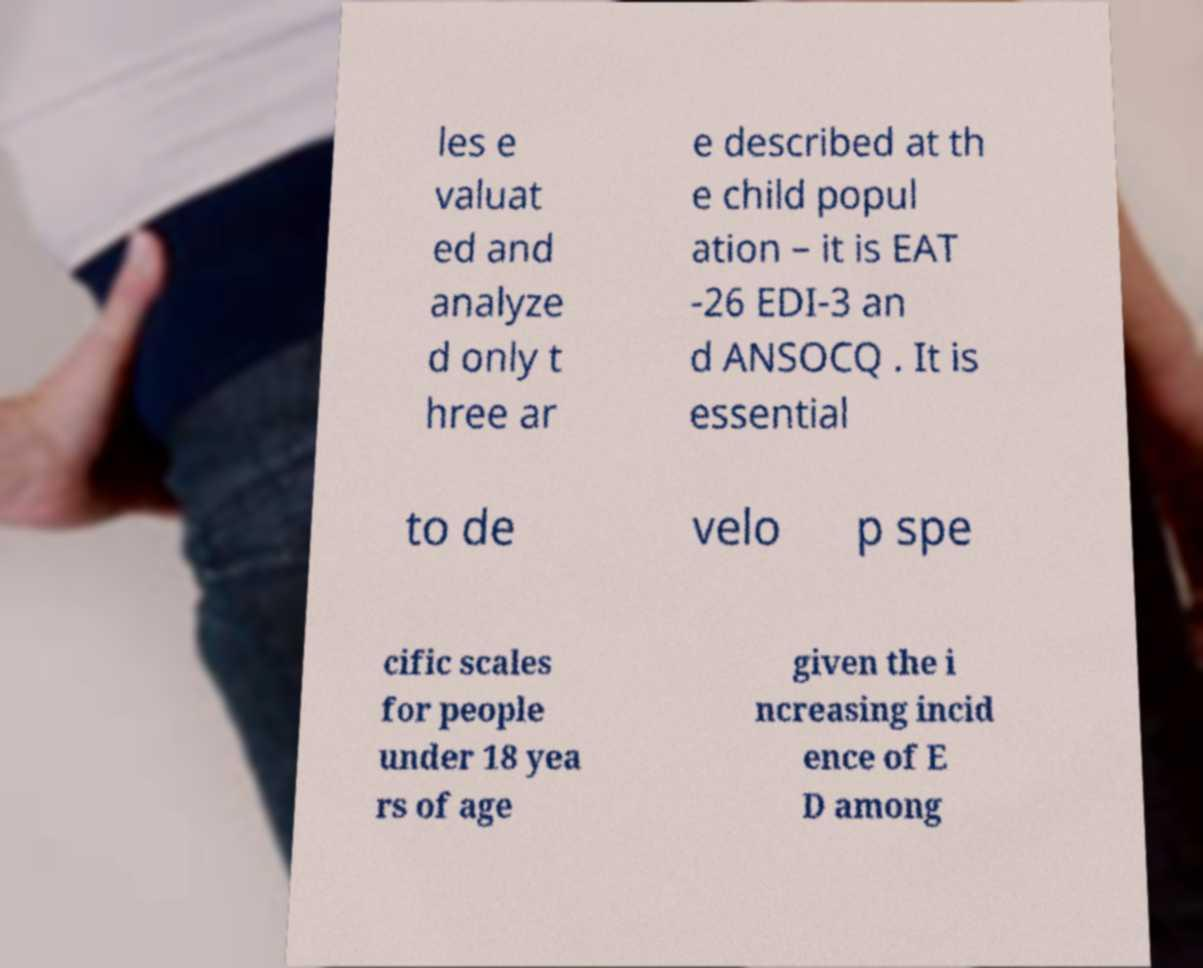Can you read and provide the text displayed in the image?This photo seems to have some interesting text. Can you extract and type it out for me? les e valuat ed and analyze d only t hree ar e described at th e child popul ation – it is EAT -26 EDI-3 an d ANSOCQ . It is essential to de velo p spe cific scales for people under 18 yea rs of age given the i ncreasing incid ence of E D among 